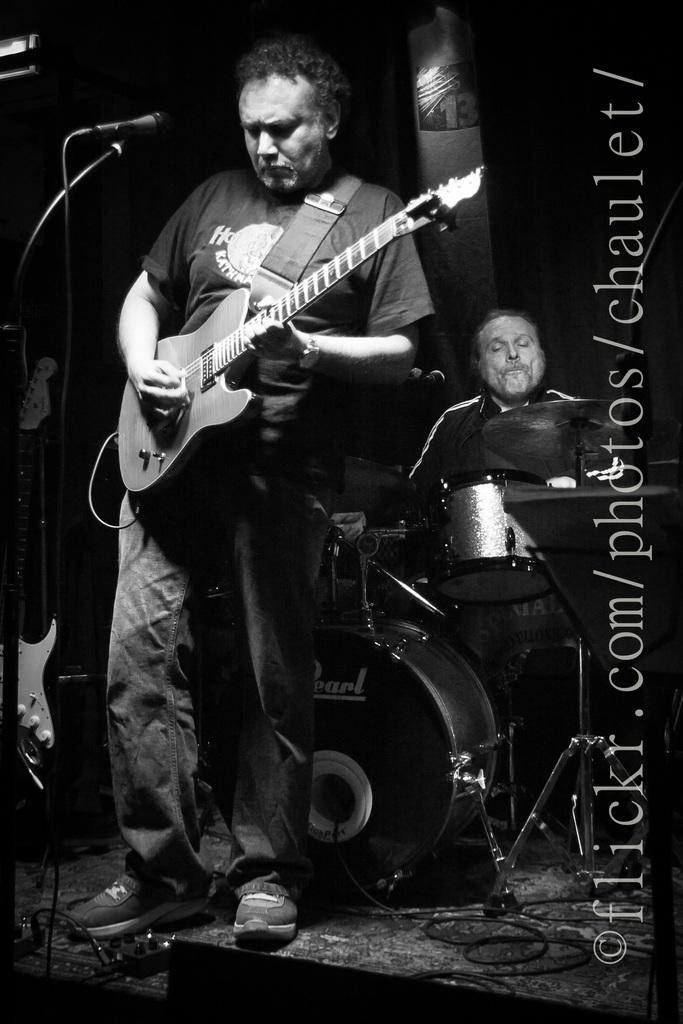What is the man on the stage doing? The man on the stage is playing a guitar. What is the man holding in his hand? The man is holding a microphone. What can be seen in front of the microphone? There is a stand in front of the microphone. What other musician can be seen in the image? There is a man playing drums in the background. What type of chicken is attacking the drummer in the image? There is no chicken or attack present in the image; it features a man playing a guitar, holding a microphone, and a drummer in the background. 